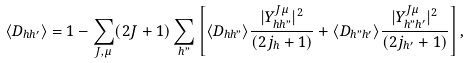<formula> <loc_0><loc_0><loc_500><loc_500>\langle D _ { h h ^ { \prime } } \rangle = 1 - \sum _ { J , { \mu } } ( 2 J + 1 ) \sum _ { h " } \left [ \langle D _ { h h " } \rangle \frac { | Y ^ { J { \mu } } _ { h h " } | ^ { 2 } } { ( 2 j _ { h } + 1 ) } + \langle D _ { h " h ^ { \prime } } \rangle \frac { | Y ^ { J { \mu } } _ { h " h ^ { \prime } } | ^ { 2 } } { ( 2 j _ { h ^ { \prime } } + 1 ) } \right ] ,</formula> 